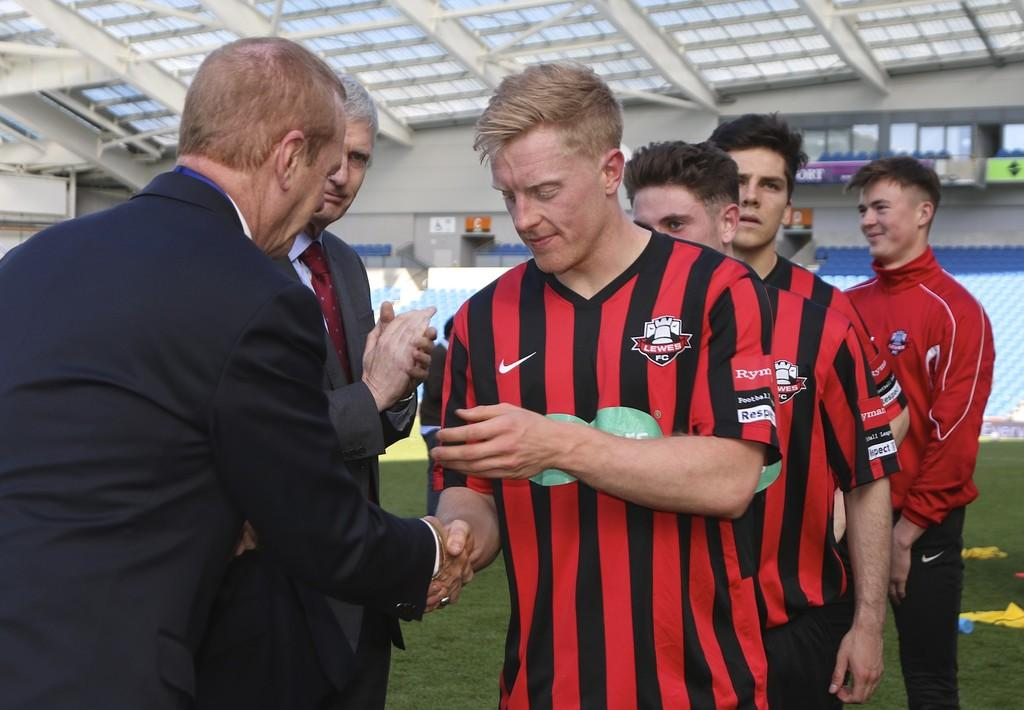What is happening in the image? There are persons standing in the image. Where are the persons located in the image? The persons are in the middle of the image. What can be seen in the background of the image? There is a wall in the background of the image. What is visible at the top of the image? There is a roof visible at the top of the image. What type of root is growing out of the elbow of the person on the left? There is no root or person on the left in the image; it only shows persons standing in the middle. 